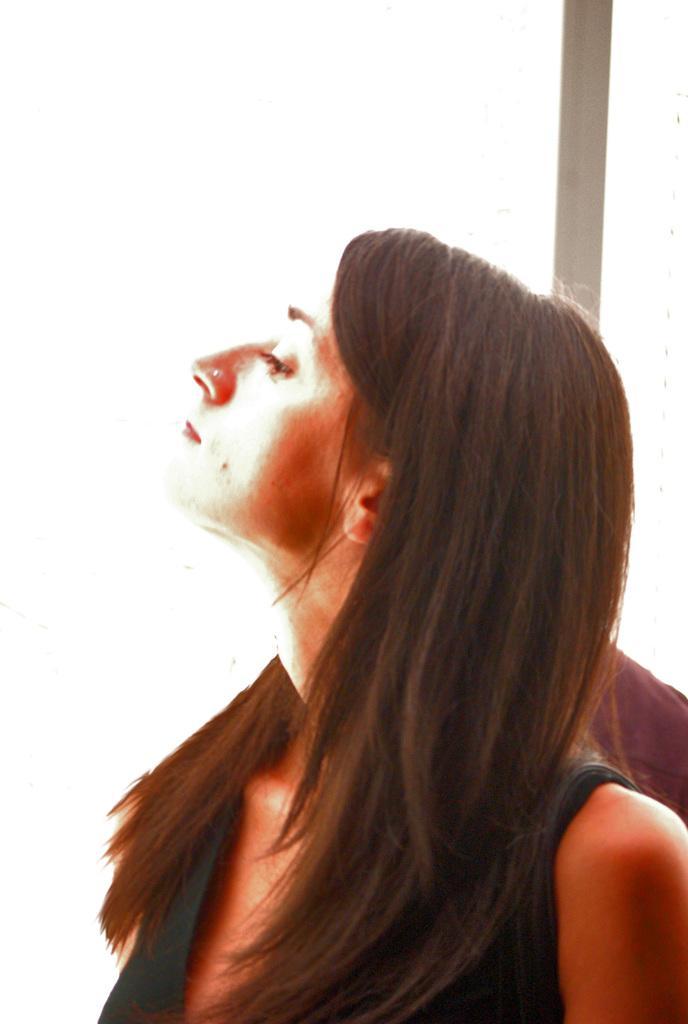In one or two sentences, can you explain what this image depicts? In the middle of this image, there is a woman in a dress, watching something. Beside her, there is a pole. And the background is white in color. 